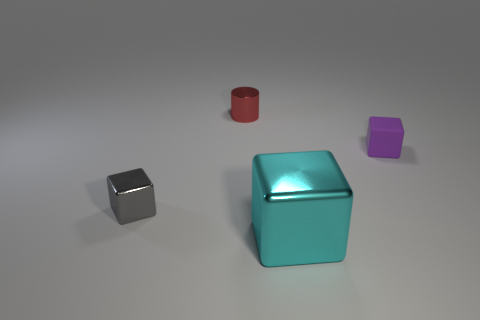Is there any other thing that is the same shape as the small gray metallic object?
Keep it short and to the point. Yes. What is the small object that is on the right side of the small red metallic object made of?
Give a very brief answer. Rubber. Is the thing that is to the left of the shiny cylinder made of the same material as the cylinder?
Your answer should be compact. Yes. How many things are either gray cubes or objects that are on the right side of the gray object?
Make the answer very short. 4. What size is the other gray thing that is the same shape as the small matte thing?
Your response must be concise. Small. Is there anything else that is the same size as the cyan metallic cube?
Your response must be concise. No. There is a rubber cube; are there any big blocks in front of it?
Keep it short and to the point. Yes. There is a shiny block that is behind the big cyan block; is it the same color as the small metallic thing that is behind the rubber object?
Your response must be concise. No. Are there any small objects that have the same shape as the large cyan thing?
Offer a terse response. Yes. How many other things are there of the same color as the large metallic block?
Keep it short and to the point. 0. 